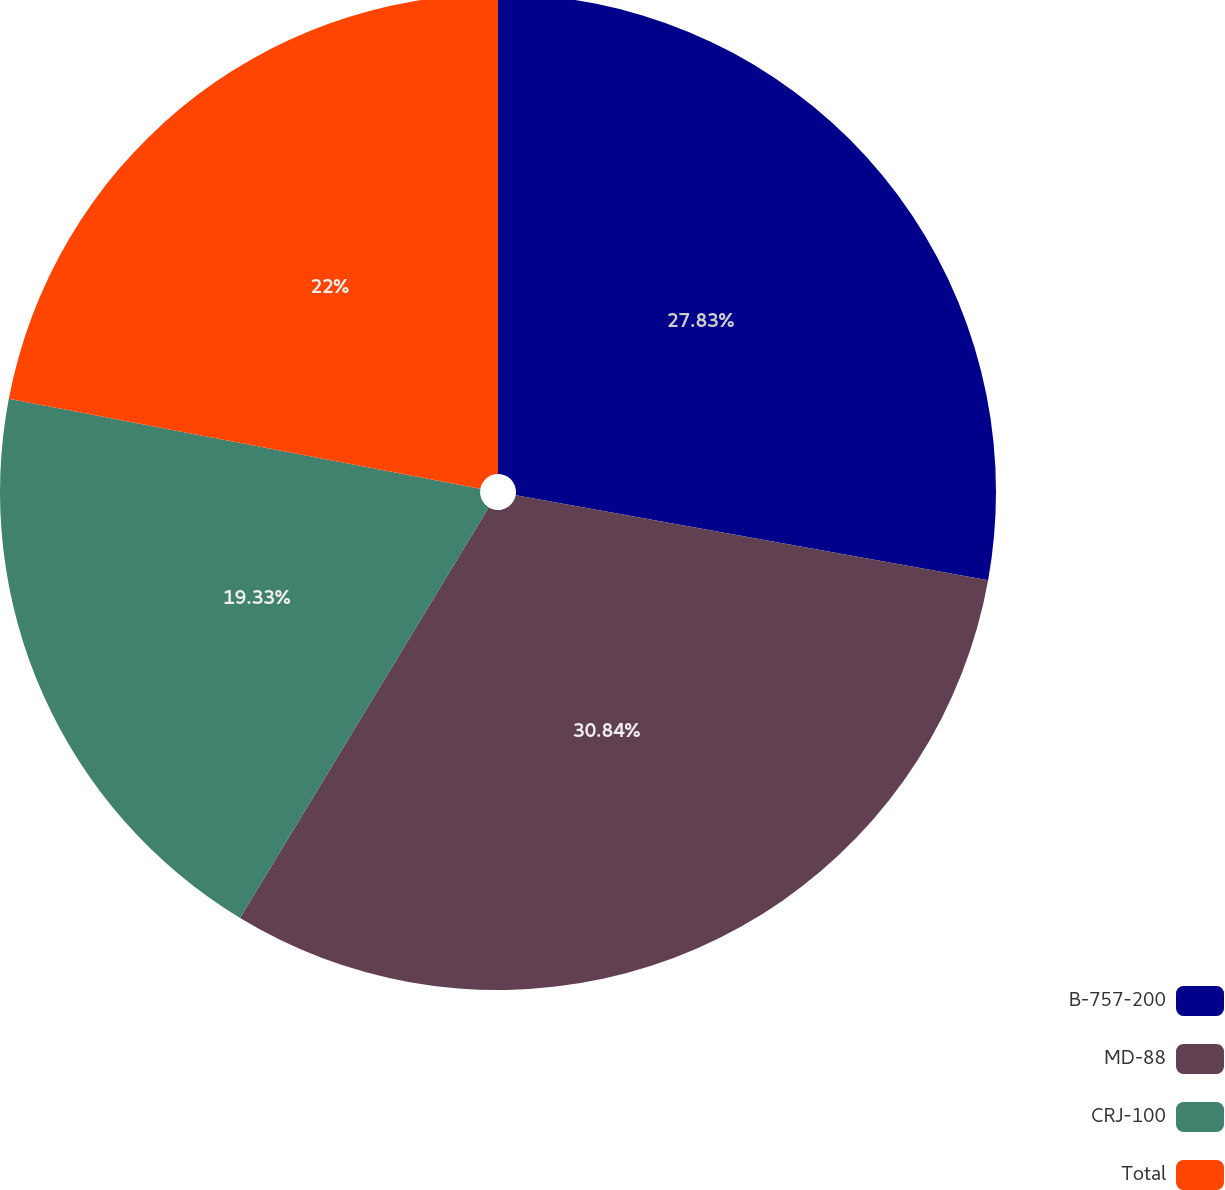Convert chart to OTSL. <chart><loc_0><loc_0><loc_500><loc_500><pie_chart><fcel>B-757-200<fcel>MD-88<fcel>CRJ-100<fcel>Total<nl><fcel>27.83%<fcel>30.83%<fcel>19.33%<fcel>22.0%<nl></chart> 